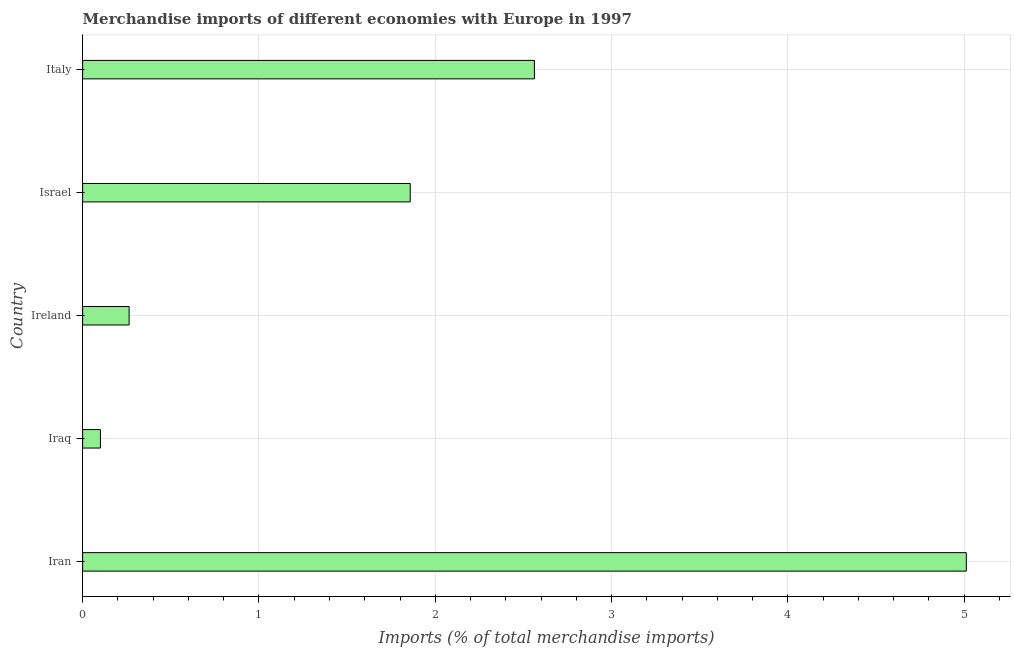Does the graph contain any zero values?
Offer a very short reply. No. Does the graph contain grids?
Give a very brief answer. Yes. What is the title of the graph?
Give a very brief answer. Merchandise imports of different economies with Europe in 1997. What is the label or title of the X-axis?
Your answer should be very brief. Imports (% of total merchandise imports). What is the label or title of the Y-axis?
Provide a short and direct response. Country. What is the merchandise imports in Ireland?
Offer a terse response. 0.26. Across all countries, what is the maximum merchandise imports?
Give a very brief answer. 5.01. Across all countries, what is the minimum merchandise imports?
Your response must be concise. 0.1. In which country was the merchandise imports maximum?
Make the answer very short. Iran. In which country was the merchandise imports minimum?
Your answer should be very brief. Iraq. What is the sum of the merchandise imports?
Your answer should be compact. 9.8. What is the difference between the merchandise imports in Iran and Italy?
Offer a terse response. 2.45. What is the average merchandise imports per country?
Give a very brief answer. 1.96. What is the median merchandise imports?
Your answer should be compact. 1.86. In how many countries, is the merchandise imports greater than 4.6 %?
Keep it short and to the point. 1. What is the ratio of the merchandise imports in Iran to that in Israel?
Keep it short and to the point. 2.7. Is the difference between the merchandise imports in Iraq and Israel greater than the difference between any two countries?
Offer a terse response. No. What is the difference between the highest and the second highest merchandise imports?
Your response must be concise. 2.45. What is the difference between the highest and the lowest merchandise imports?
Offer a terse response. 4.91. In how many countries, is the merchandise imports greater than the average merchandise imports taken over all countries?
Provide a short and direct response. 2. How many bars are there?
Provide a short and direct response. 5. What is the difference between two consecutive major ticks on the X-axis?
Provide a short and direct response. 1. What is the Imports (% of total merchandise imports) of Iran?
Your answer should be very brief. 5.01. What is the Imports (% of total merchandise imports) in Iraq?
Provide a succinct answer. 0.1. What is the Imports (% of total merchandise imports) in Ireland?
Provide a succinct answer. 0.26. What is the Imports (% of total merchandise imports) of Israel?
Keep it short and to the point. 1.86. What is the Imports (% of total merchandise imports) in Italy?
Provide a short and direct response. 2.56. What is the difference between the Imports (% of total merchandise imports) in Iran and Iraq?
Your response must be concise. 4.91. What is the difference between the Imports (% of total merchandise imports) in Iran and Ireland?
Provide a succinct answer. 4.75. What is the difference between the Imports (% of total merchandise imports) in Iran and Israel?
Offer a very short reply. 3.15. What is the difference between the Imports (% of total merchandise imports) in Iran and Italy?
Ensure brevity in your answer.  2.45. What is the difference between the Imports (% of total merchandise imports) in Iraq and Ireland?
Offer a very short reply. -0.16. What is the difference between the Imports (% of total merchandise imports) in Iraq and Israel?
Your answer should be very brief. -1.76. What is the difference between the Imports (% of total merchandise imports) in Iraq and Italy?
Offer a very short reply. -2.46. What is the difference between the Imports (% of total merchandise imports) in Ireland and Israel?
Ensure brevity in your answer.  -1.59. What is the difference between the Imports (% of total merchandise imports) in Ireland and Italy?
Provide a succinct answer. -2.3. What is the difference between the Imports (% of total merchandise imports) in Israel and Italy?
Make the answer very short. -0.7. What is the ratio of the Imports (% of total merchandise imports) in Iran to that in Iraq?
Keep it short and to the point. 49.66. What is the ratio of the Imports (% of total merchandise imports) in Iran to that in Ireland?
Provide a short and direct response. 19.02. What is the ratio of the Imports (% of total merchandise imports) in Iran to that in Israel?
Keep it short and to the point. 2.7. What is the ratio of the Imports (% of total merchandise imports) in Iran to that in Italy?
Make the answer very short. 1.96. What is the ratio of the Imports (% of total merchandise imports) in Iraq to that in Ireland?
Keep it short and to the point. 0.38. What is the ratio of the Imports (% of total merchandise imports) in Iraq to that in Israel?
Make the answer very short. 0.05. What is the ratio of the Imports (% of total merchandise imports) in Iraq to that in Italy?
Offer a very short reply. 0.04. What is the ratio of the Imports (% of total merchandise imports) in Ireland to that in Israel?
Keep it short and to the point. 0.14. What is the ratio of the Imports (% of total merchandise imports) in Ireland to that in Italy?
Offer a very short reply. 0.1. What is the ratio of the Imports (% of total merchandise imports) in Israel to that in Italy?
Offer a very short reply. 0.72. 